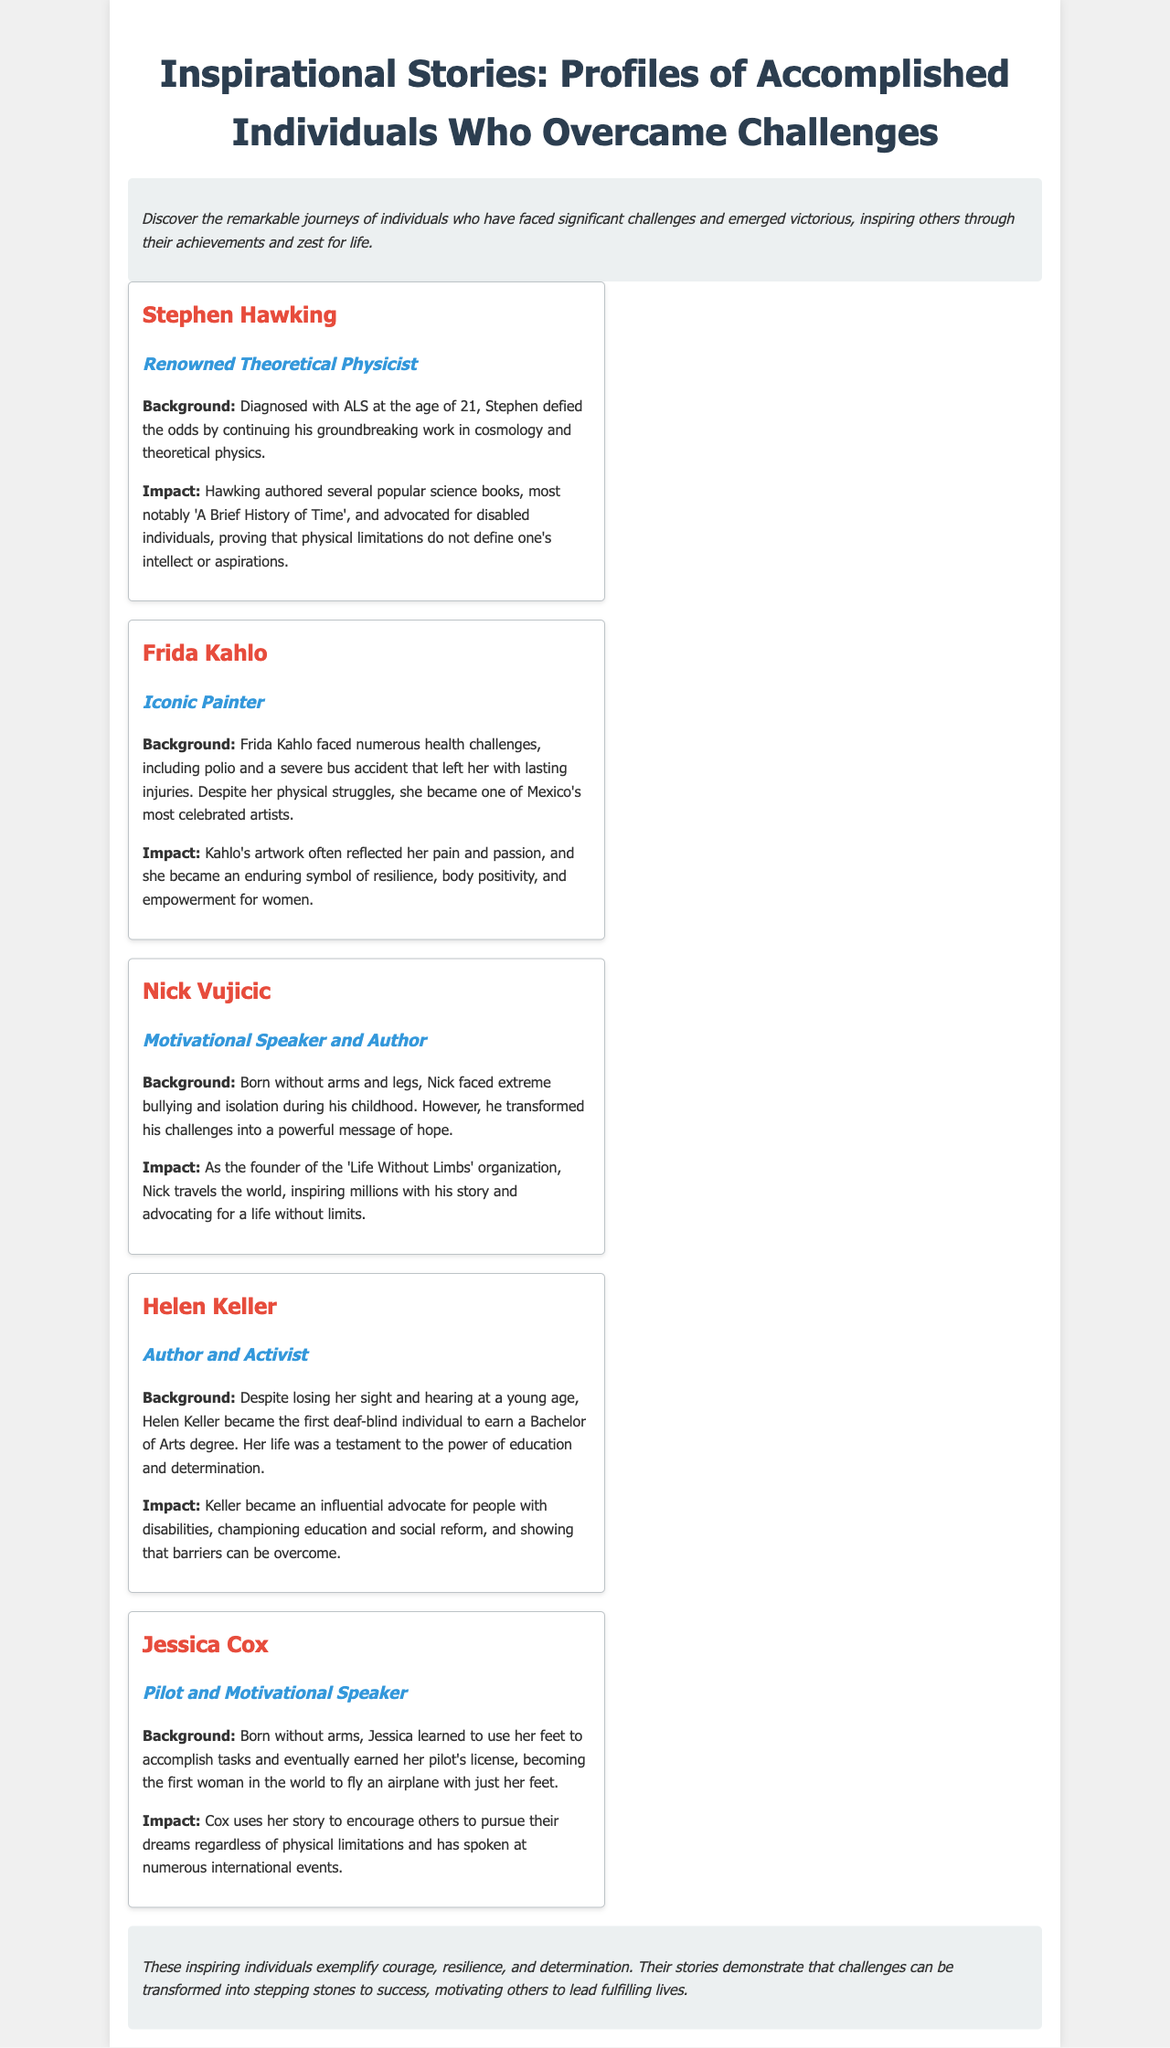what is the title of the brochure? The title of the brochure, prominently displayed at the top, summarizes the content focus on inspirational figures.
Answer: Inspirational Stories: Profiles of Accomplished Individuals Who Overcame Challenges to Lead Fulfilling Lives who is the first profile mentioned? The first individual highlighted in the profiles section of the brochure.
Answer: Stephen Hawking what challenge did Frida Kahlo face? The brochure details her health struggles including polio and a severe bus accident.
Answer: Polio and a severe bus accident what organization did Nick Vujicic found? The brochure identifies the organization he created to inspire others.
Answer: Life Without Limbs who was the first deaf-blind individual to earn a Bachelor of Arts degree? The profile of Helen Keller contains this significant accomplishment in education.
Answer: Helen Keller which individual became the first woman to fly an airplane with just her feet? The document states Jessica Cox's remarkable achievement.
Answer: Jessica Cox what is the common theme among the profiles? Each profile illustrates a significant trait highlighted in the introductions and conclusions.
Answer: Resilience how does the document categorize the stories being shared? The introduction articulates how the document presents personal stories through the lens of overcoming adversity.
Answer: Inspirational stories 